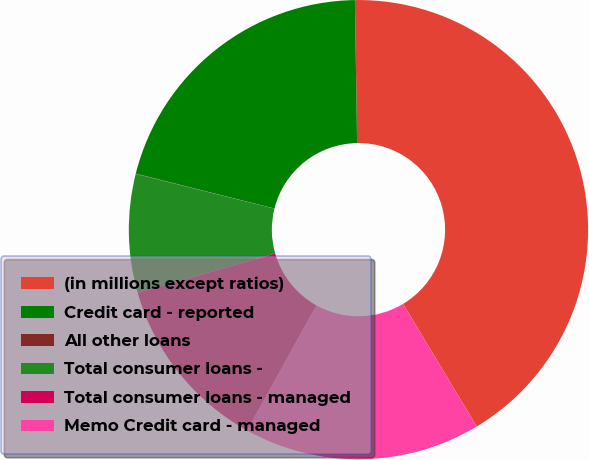Convert chart. <chart><loc_0><loc_0><loc_500><loc_500><pie_chart><fcel>(in millions except ratios)<fcel>Credit card - reported<fcel>All other loans<fcel>Total consumer loans -<fcel>Total consumer loans - managed<fcel>Memo Credit card - managed<nl><fcel>41.64%<fcel>20.83%<fcel>0.02%<fcel>8.34%<fcel>12.51%<fcel>16.67%<nl></chart> 